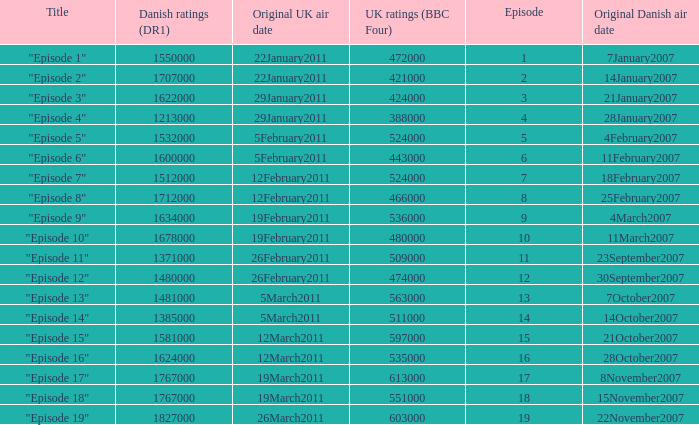What is the original Danish air date of "Episode 17"?  8November2007. 